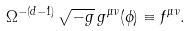Convert formula to latex. <formula><loc_0><loc_0><loc_500><loc_500>\Omega ^ { - ( d - 1 ) } \, \sqrt { - g } \, g ^ { \mu \nu } ( \phi ) \equiv f ^ { \mu \nu } .</formula> 